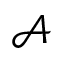Convert formula to latex. <formula><loc_0><loc_0><loc_500><loc_500>\mathcal { A }</formula> 